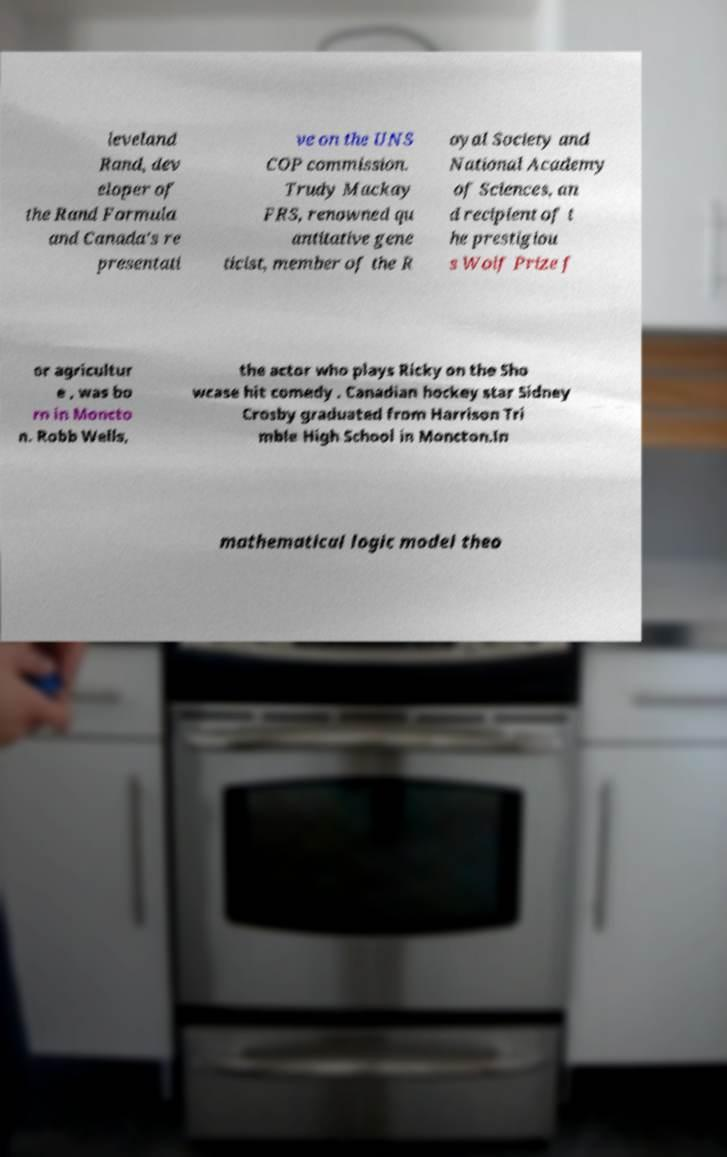Please identify and transcribe the text found in this image. leveland Rand, dev eloper of the Rand Formula and Canada's re presentati ve on the UNS COP commission. Trudy Mackay FRS, renowned qu antitative gene ticist, member of the R oyal Society and National Academy of Sciences, an d recipient of t he prestigiou s Wolf Prize f or agricultur e , was bo rn in Moncto n. Robb Wells, the actor who plays Ricky on the Sho wcase hit comedy . Canadian hockey star Sidney Crosby graduated from Harrison Tri mble High School in Moncton.In mathematical logic model theo 